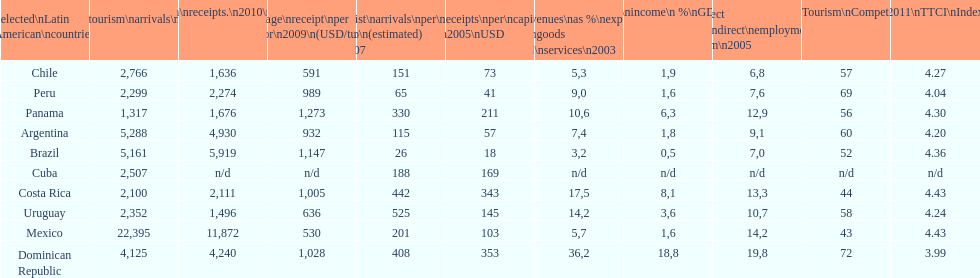What country had the most receipts per capita in 2005? Dominican Republic. Can you parse all the data within this table? {'header': ['Selected\\nLatin American\\ncountries', 'Internl.\\ntourism\\narrivals\\n2010\\n(x 1000)', 'Internl.\\ntourism\\nreceipts.\\n2010\\n(USD\\n(x1000)', 'Average\\nreceipt\\nper visitor\\n2009\\n(USD/turista)', 'Tourist\\narrivals\\nper\\n1000 inhab\\n(estimated) \\n2007', 'Receipts\\nper\\ncapita \\n2005\\nUSD', 'Revenues\\nas\xa0%\\nexports of\\ngoods and\\nservices\\n2003', 'Tourism\\nincome\\n\xa0%\\nGDP\\n2003', '% Direct and\\nindirect\\nemployment\\nin tourism\\n2005', 'World\\nranking\\nTourism\\nCompetitiv.\\nTTCI\\n2011', '2011\\nTTCI\\nIndex'], 'rows': [['Chile', '2,766', '1,636', '591', '151', '73', '5,3', '1,9', '6,8', '57', '4.27'], ['Peru', '2,299', '2,274', '989', '65', '41', '9,0', '1,6', '7,6', '69', '4.04'], ['Panama', '1,317', '1,676', '1,273', '330', '211', '10,6', '6,3', '12,9', '56', '4.30'], ['Argentina', '5,288', '4,930', '932', '115', '57', '7,4', '1,8', '9,1', '60', '4.20'], ['Brazil', '5,161', '5,919', '1,147', '26', '18', '3,2', '0,5', '7,0', '52', '4.36'], ['Cuba', '2,507', 'n/d', 'n/d', '188', '169', 'n/d', 'n/d', 'n/d', 'n/d', 'n/d'], ['Costa Rica', '2,100', '2,111', '1,005', '442', '343', '17,5', '8,1', '13,3', '44', '4.43'], ['Uruguay', '2,352', '1,496', '636', '525', '145', '14,2', '3,6', '10,7', '58', '4.24'], ['Mexico', '22,395', '11,872', '530', '201', '103', '5,7', '1,6', '14,2', '43', '4.43'], ['Dominican Republic', '4,125', '4,240', '1,028', '408', '353', '36,2', '18,8', '19,8', '72', '3.99']]} 